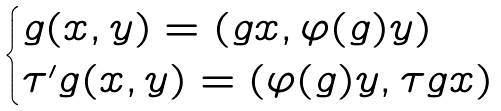Convert formula to latex. <formula><loc_0><loc_0><loc_500><loc_500>\begin{cases} g ( x , y ) = ( g x , \varphi ( g ) y ) \\ \tau ^ { \prime } g ( x , y ) = ( \varphi ( g ) y , \tau g x ) \end{cases}</formula> 